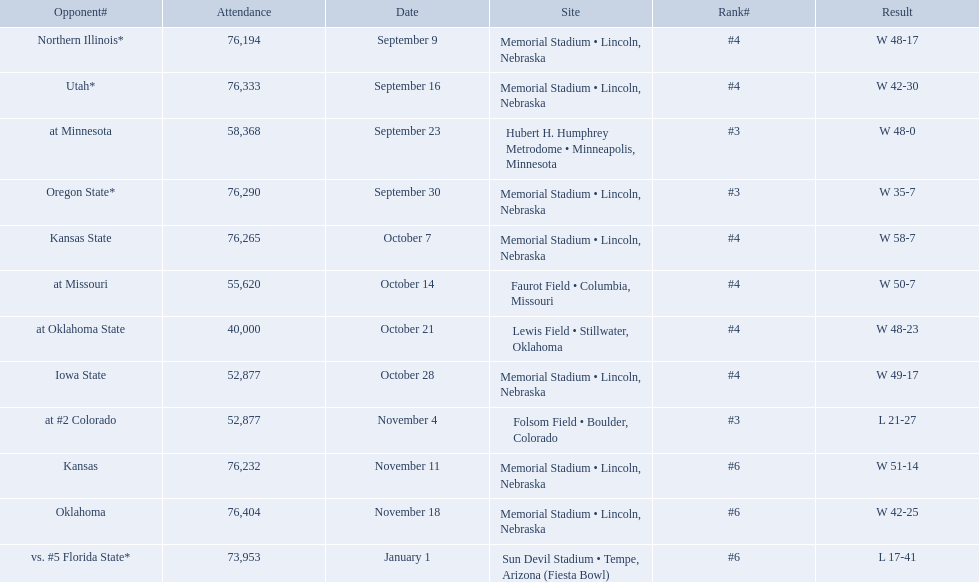When did nebraska play oregon state? September 30. What was the attendance at the september 30 game? 76,290. 